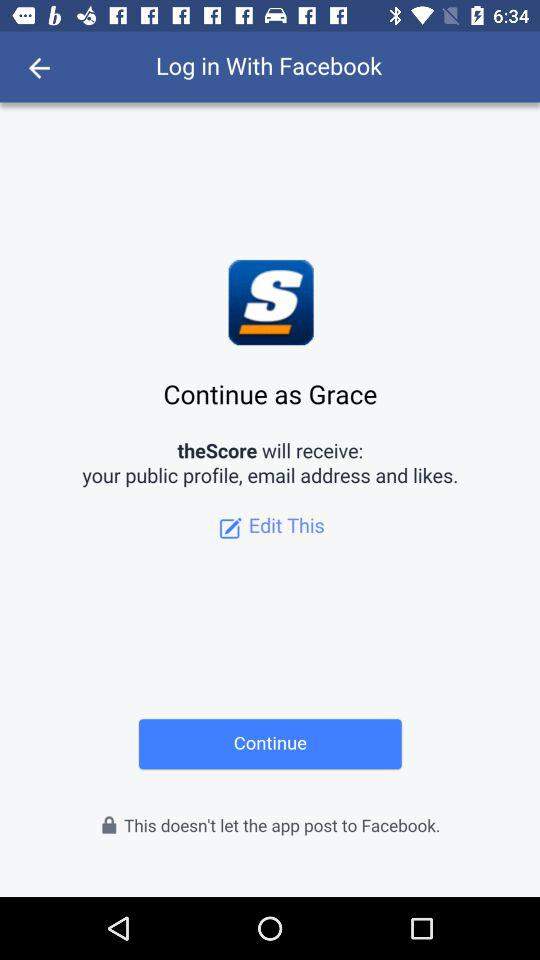What is the name of the user? The name of the user is Grace. 